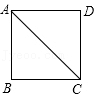Could you explain how to compute the area and perimeter of square ABCD? The area of square ABCD can be found by squaring the length of one of its sides. Given each side is 1 unit, the area is 1^2 = 1 square unit. The perimeter of the square is calculated by summing the lengths of all its sides. Since each side of square ABCD is 1 unit, the perimeter would be 1 + 1 + 1 + 1 = 4 units. 